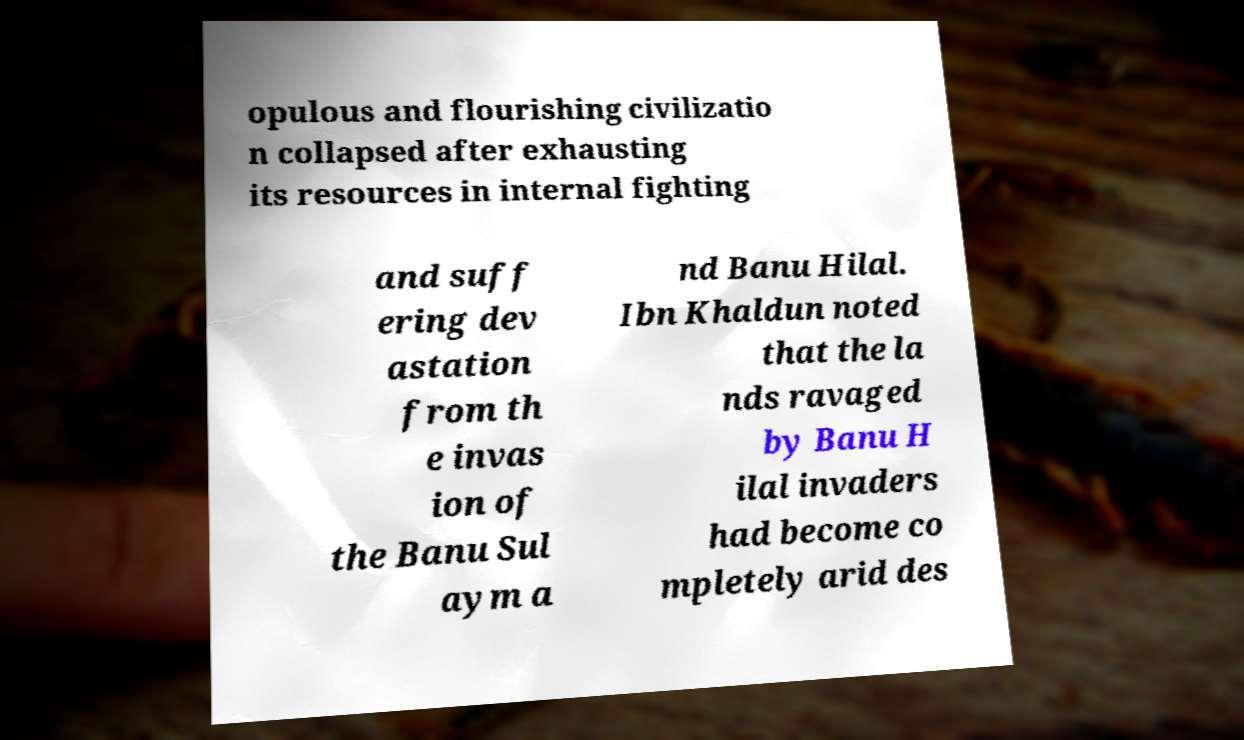Please read and relay the text visible in this image. What does it say? opulous and flourishing civilizatio n collapsed after exhausting its resources in internal fighting and suff ering dev astation from th e invas ion of the Banu Sul aym a nd Banu Hilal. Ibn Khaldun noted that the la nds ravaged by Banu H ilal invaders had become co mpletely arid des 